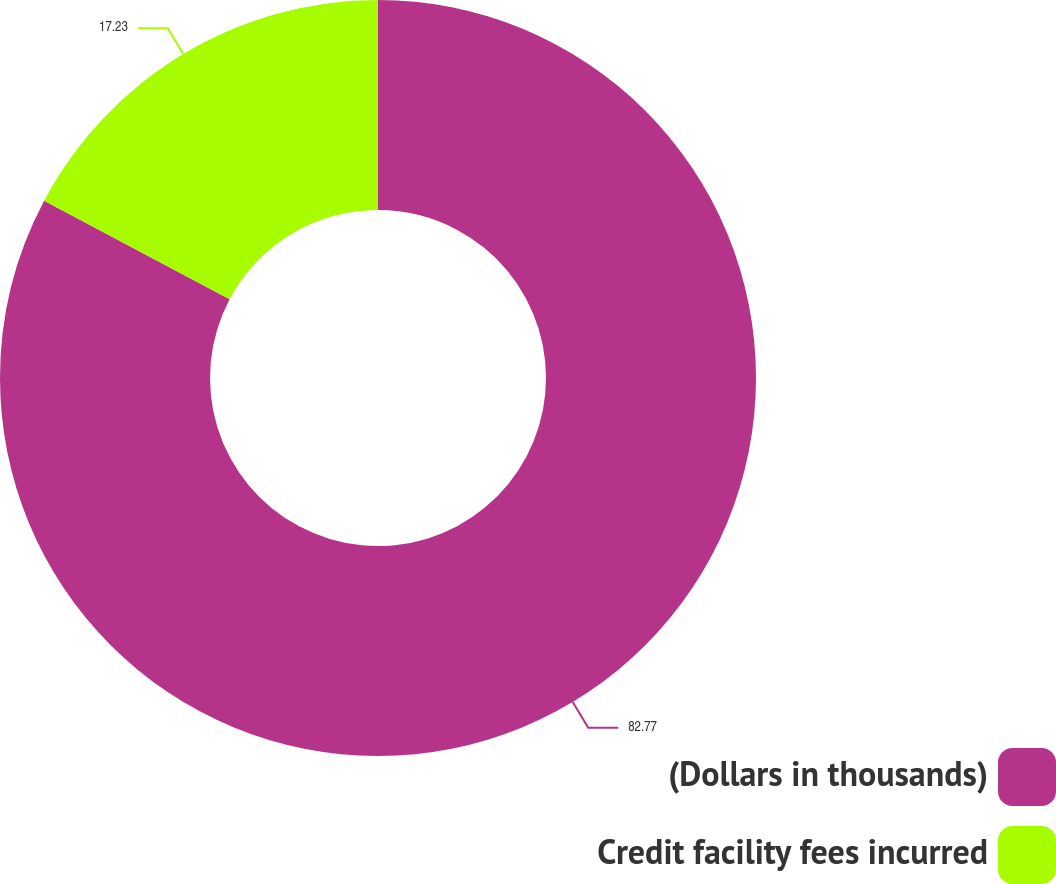Convert chart. <chart><loc_0><loc_0><loc_500><loc_500><pie_chart><fcel>(Dollars in thousands)<fcel>Credit facility fees incurred<nl><fcel>82.77%<fcel>17.23%<nl></chart> 